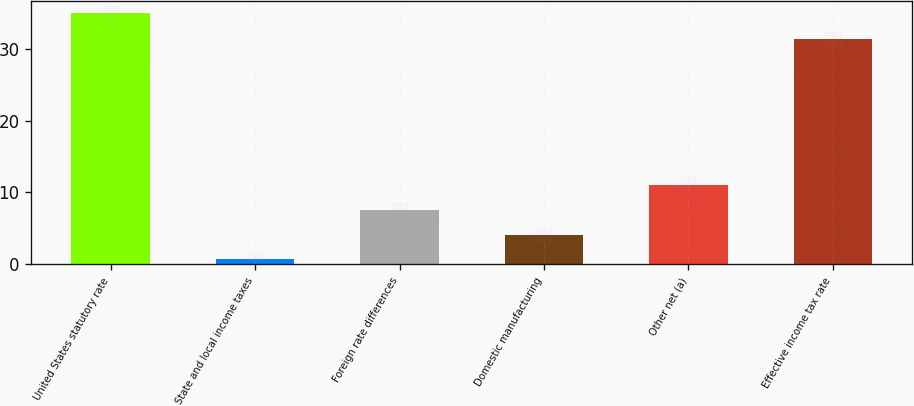<chart> <loc_0><loc_0><loc_500><loc_500><bar_chart><fcel>United States statutory rate<fcel>State and local income taxes<fcel>Foreign rate differences<fcel>Domestic manufacturing<fcel>Other net (a)<fcel>Effective income tax rate<nl><fcel>35<fcel>0.7<fcel>7.56<fcel>4.13<fcel>10.99<fcel>31.4<nl></chart> 